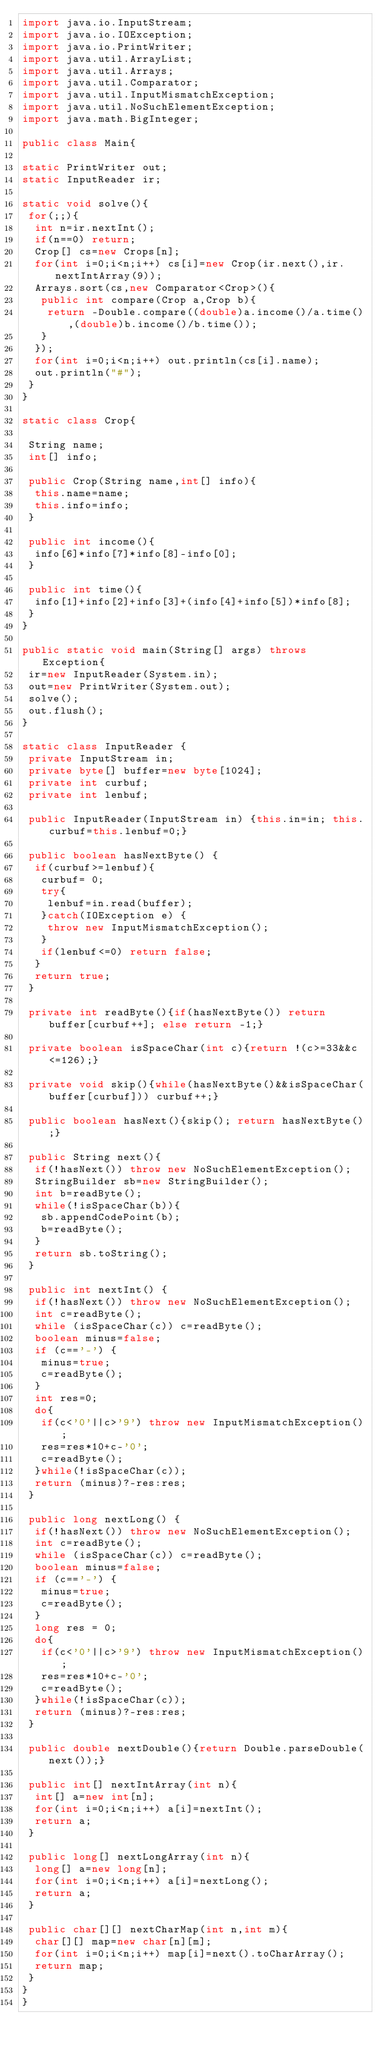<code> <loc_0><loc_0><loc_500><loc_500><_Java_>import java.io.InputStream;
import java.io.IOException;
import java.io.PrintWriter;
import java.util.ArrayList;
import java.util.Arrays;
import java.util.Comparator;
import java.util.InputMismatchException;
import java.util.NoSuchElementException;
import java.math.BigInteger;

public class Main{

static PrintWriter out;
static InputReader ir;

static void solve(){
 for(;;){
  int n=ir.nextInt();
  if(n==0) return;
  Crop[] cs=new Crops[n];
  for(int i=0;i<n;i++) cs[i]=new Crop(ir.next(),ir.nextIntArray(9));
  Arrays.sort(cs,new Comparator<Crop>(){
   public int compare(Crop a,Crop b){
    return -Double.compare((double)a.income()/a.time(),(double)b.income()/b.time());
   }
  });
  for(int i=0;i<n;i++) out.println(cs[i].name);
  out.println("#");
 }
}

static class Crop{

 String name;
 int[] info;

 public Crop(String name,int[] info){
  this.name=name;
  this.info=info;
 }

 public int income(){
  info[6]*info[7]*info[8]-info[0];
 }

 public int time(){
  info[1]+info[2]+info[3]+(info[4]+info[5])*info[8];
 }
}

public static void main(String[] args) throws Exception{
 ir=new InputReader(System.in);
 out=new PrintWriter(System.out);
 solve();
 out.flush();
}

static class InputReader {
 private InputStream in;
 private byte[] buffer=new byte[1024];
 private int curbuf;
 private int lenbuf;

 public InputReader(InputStream in) {this.in=in; this.curbuf=this.lenbuf=0;}
 
 public boolean hasNextByte() {
  if(curbuf>=lenbuf){
   curbuf= 0;
   try{
    lenbuf=in.read(buffer);
   }catch(IOException e) {
    throw new InputMismatchException();
   }
   if(lenbuf<=0) return false;
  }
  return true;
 }

 private int readByte(){if(hasNextByte()) return buffer[curbuf++]; else return -1;}
 
 private boolean isSpaceChar(int c){return !(c>=33&&c<=126);}
 
 private void skip(){while(hasNextByte()&&isSpaceChar(buffer[curbuf])) curbuf++;}
 
 public boolean hasNext(){skip(); return hasNextByte();}
 
 public String next(){
  if(!hasNext()) throw new NoSuchElementException();
  StringBuilder sb=new StringBuilder();
  int b=readByte();
  while(!isSpaceChar(b)){
   sb.appendCodePoint(b);
   b=readByte();
  }
  return sb.toString();
 }
 
 public int nextInt() {
  if(!hasNext()) throw new NoSuchElementException();
  int c=readByte();
  while (isSpaceChar(c)) c=readByte();
  boolean minus=false;
  if (c=='-') {
   minus=true;
   c=readByte();
  }
  int res=0;
  do{
   if(c<'0'||c>'9') throw new InputMismatchException();
   res=res*10+c-'0';
   c=readByte();
  }while(!isSpaceChar(c));
  return (minus)?-res:res;
 }
 
 public long nextLong() {
  if(!hasNext()) throw new NoSuchElementException();
  int c=readByte();
  while (isSpaceChar(c)) c=readByte();
  boolean minus=false;
  if (c=='-') {
   minus=true;
   c=readByte();
  }
  long res = 0;
  do{
   if(c<'0'||c>'9') throw new InputMismatchException();
   res=res*10+c-'0';
   c=readByte();
  }while(!isSpaceChar(c));
  return (minus)?-res:res;
 }

 public double nextDouble(){return Double.parseDouble(next());}

 public int[] nextIntArray(int n){
  int[] a=new int[n];
  for(int i=0;i<n;i++) a[i]=nextInt();
  return a;
 }

 public long[] nextLongArray(int n){
  long[] a=new long[n];
  for(int i=0;i<n;i++) a[i]=nextLong();
  return a;
 }

 public char[][] nextCharMap(int n,int m){
  char[][] map=new char[n][m];
  for(int i=0;i<n;i++) map[i]=next().toCharArray();
  return map;
 }
}
}</code> 